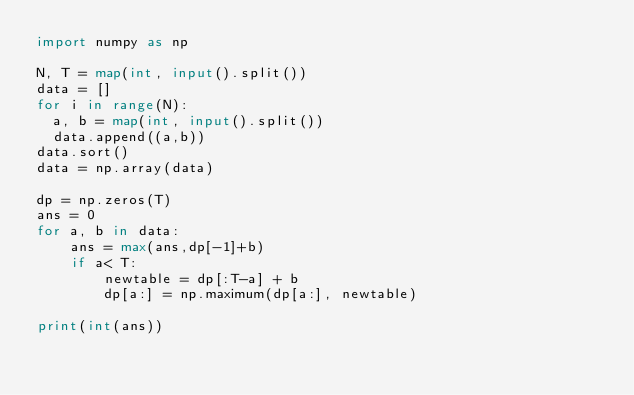Convert code to text. <code><loc_0><loc_0><loc_500><loc_500><_Python_>import numpy as np
 
N, T = map(int, input().split())
data = []
for i in range(N):
  a, b = map(int, input().split())
  data.append((a,b))
data.sort()
data = np.array(data)

dp = np.zeros(T)
ans = 0
for a, b in data:
    ans = max(ans,dp[-1]+b)
    if a< T:
        newtable = dp[:T-a] + b
        dp[a:] = np.maximum(dp[a:], newtable)

print(int(ans))</code> 